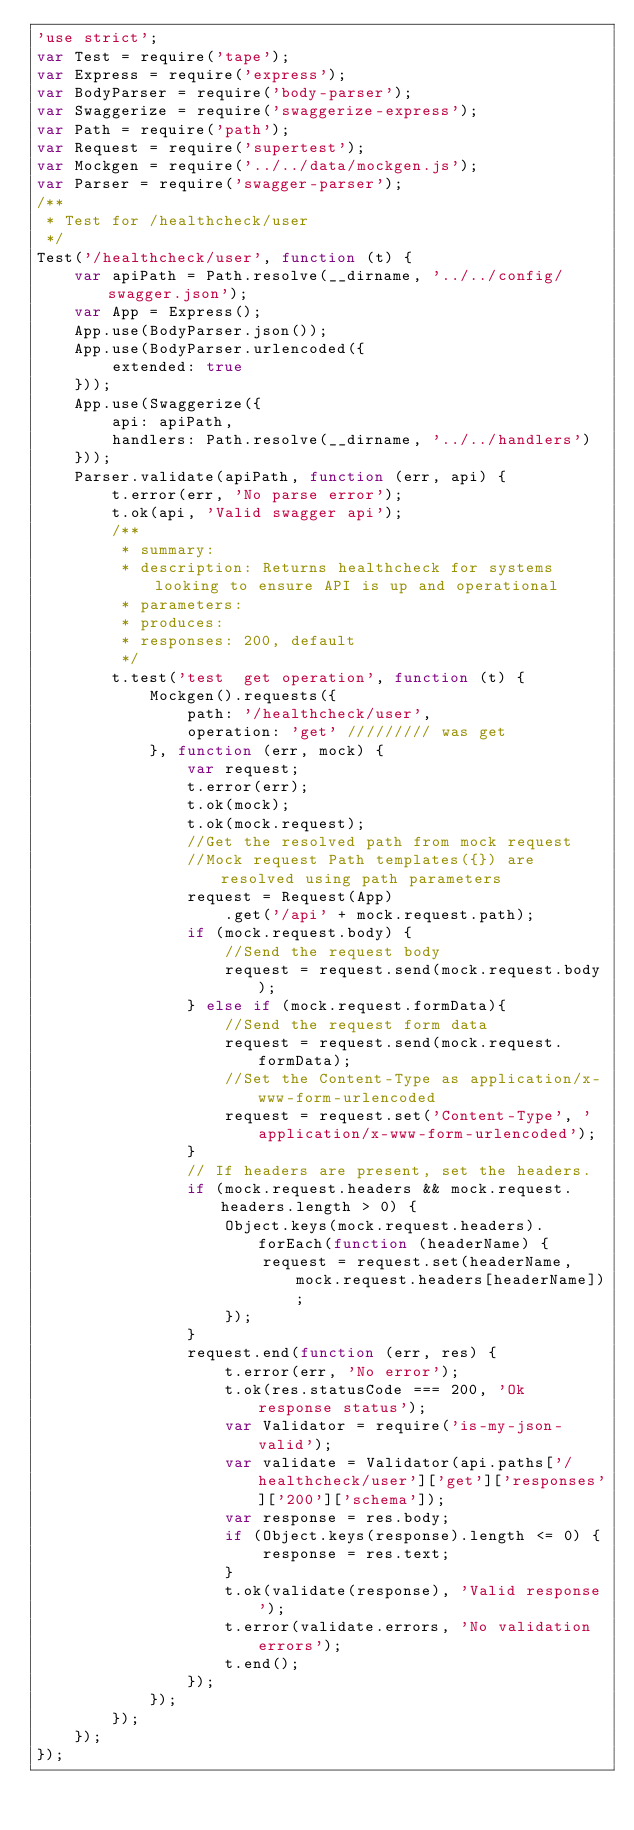Convert code to text. <code><loc_0><loc_0><loc_500><loc_500><_JavaScript_>'use strict';
var Test = require('tape');
var Express = require('express');
var BodyParser = require('body-parser');
var Swaggerize = require('swaggerize-express');
var Path = require('path');
var Request = require('supertest');
var Mockgen = require('../../data/mockgen.js');
var Parser = require('swagger-parser');
/**
 * Test for /healthcheck/user
 */
Test('/healthcheck/user', function (t) {
    var apiPath = Path.resolve(__dirname, '../../config/swagger.json');
    var App = Express();
    App.use(BodyParser.json());
    App.use(BodyParser.urlencoded({
        extended: true
    }));
    App.use(Swaggerize({
        api: apiPath,
        handlers: Path.resolve(__dirname, '../../handlers')
    }));
    Parser.validate(apiPath, function (err, api) {
        t.error(err, 'No parse error');
        t.ok(api, 'Valid swagger api');
        /**
         * summary: 
         * description: Returns healthcheck for systems looking to ensure API is up and operational
         * parameters: 
         * produces: 
         * responses: 200, default
         */
        t.test('test  get operation', function (t) {
            Mockgen().requests({
                path: '/healthcheck/user',
                operation: 'get' ///////// was get
            }, function (err, mock) {
                var request;
                t.error(err);
                t.ok(mock);
                t.ok(mock.request);
                //Get the resolved path from mock request
                //Mock request Path templates({}) are resolved using path parameters
                request = Request(App)
                    .get('/api' + mock.request.path);
                if (mock.request.body) {
                    //Send the request body
                    request = request.send(mock.request.body);
                } else if (mock.request.formData){
                    //Send the request form data
                    request = request.send(mock.request.formData);
                    //Set the Content-Type as application/x-www-form-urlencoded
                    request = request.set('Content-Type', 'application/x-www-form-urlencoded');
                }
                // If headers are present, set the headers.
                if (mock.request.headers && mock.request.headers.length > 0) {
                    Object.keys(mock.request.headers).forEach(function (headerName) {
                        request = request.set(headerName, mock.request.headers[headerName]);
                    });
                }
                request.end(function (err, res) {
                    t.error(err, 'No error');
                    t.ok(res.statusCode === 200, 'Ok response status');
                    var Validator = require('is-my-json-valid');
                    var validate = Validator(api.paths['/healthcheck/user']['get']['responses']['200']['schema']);
                    var response = res.body;
                    if (Object.keys(response).length <= 0) {
                        response = res.text;
                    }
                    t.ok(validate(response), 'Valid response');
                    t.error(validate.errors, 'No validation errors');
                    t.end();
                });
            });
        });
    });
});
</code> 